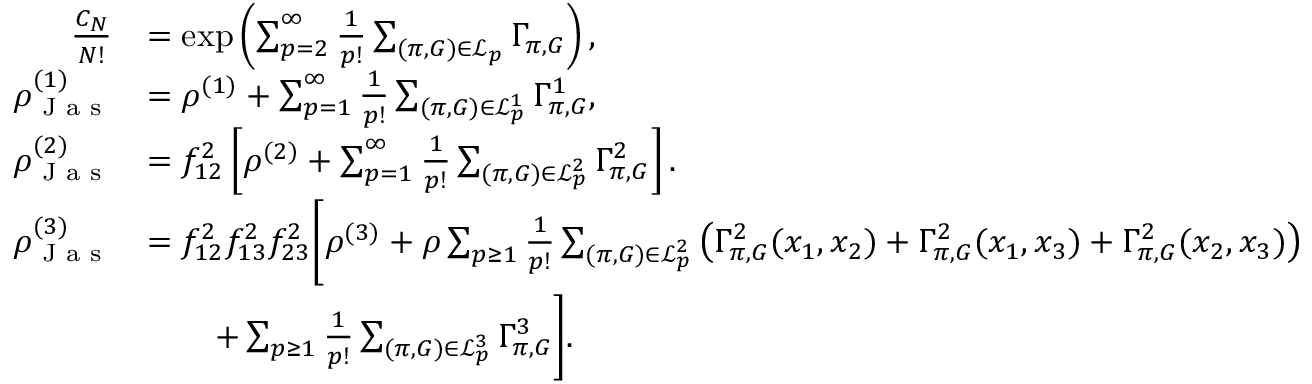Convert formula to latex. <formula><loc_0><loc_0><loc_500><loc_500>\begin{array} { r l } { \frac { C _ { N } } { N ! } } & { = \exp \left ( \sum _ { p = 2 } ^ { \infty } \frac { 1 } { p ! } \sum _ { ( \pi , G ) \in \mathcal { L } _ { p } } \Gamma _ { \pi , G } \right ) , } \\ { \rho _ { J a s } ^ { ( 1 ) } } & { = \rho ^ { ( 1 ) } + \sum _ { p = 1 } ^ { \infty } \frac { 1 } { p ! } \sum _ { ( \pi , G ) \in \mathcal { L } _ { p } ^ { 1 } } \Gamma _ { \pi , G } ^ { 1 } , } \\ { \rho _ { J a s } ^ { ( 2 ) } } & { = f _ { 1 2 } ^ { 2 } \left [ \rho ^ { ( 2 ) } + \sum _ { p = 1 } ^ { \infty } \frac { 1 } { p ! } \sum _ { ( \pi , G ) \in \mathcal { L } _ { p } ^ { 2 } } \Gamma _ { \pi , G } ^ { 2 } \right ] . } \\ { \rho _ { J a s } ^ { ( 3 ) } } & { = f _ { 1 2 } ^ { 2 } f _ { 1 3 } ^ { 2 } f _ { 2 3 } ^ { 2 } \left [ \rho ^ { ( 3 ) } + \rho \sum _ { p \geq 1 } \frac { 1 } { p ! } \sum _ { ( \pi , G ) \in \mathcal { L } _ { p } ^ { 2 } } \left ( \Gamma _ { \pi , G } ^ { 2 } ( x _ { 1 } , x _ { 2 } ) + \Gamma _ { \pi , G } ^ { 2 } ( x _ { 1 } , x _ { 3 } ) + \Gamma _ { \pi , G } ^ { 2 } ( x _ { 2 } , x _ { 3 } ) \right ) } \\ & { \quad + \sum _ { p \geq 1 } \frac { 1 } { p ! } \sum _ { ( \pi , G ) \in \mathcal { L } _ { p } ^ { 3 } } \Gamma _ { \pi , G } ^ { 3 } \right ] . } \end{array}</formula> 